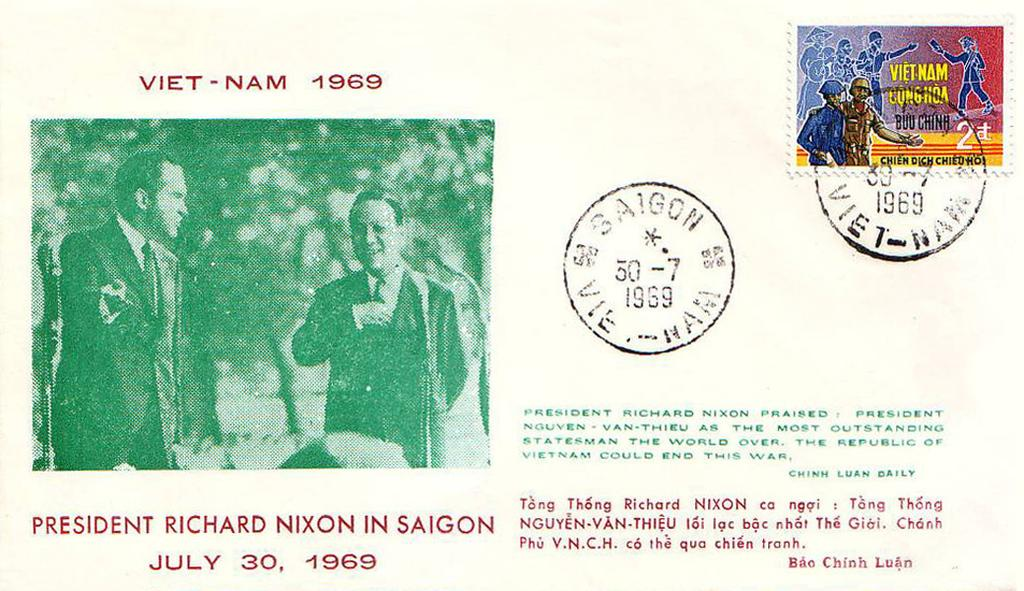How many people are present in the image? There are two persons in the image. What else can be seen in the image besides the people? There are stamps in the image. Is there any text or writing visible in the image? Yes, there is text or writing visible in the image. What type of form is the beggar holding in the image? There is no beggar or form present in the image. What unit of measurement is used to determine the size of the stamps in the image? The size of the stamps in the image is not specified, and there is no mention of any unit of measurement. 